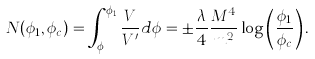<formula> <loc_0><loc_0><loc_500><loc_500>N ( \phi _ { 1 } , \phi _ { c } ) = \int _ { \phi _ { c } } ^ { \phi _ { 1 } } \frac { V } { V ^ { \prime } } d \phi = \pm \frac { \lambda } { 4 } \frac { M ^ { 4 } } { m ^ { 2 } } \log \left ( \frac { \phi _ { 1 } } { \phi _ { c } } \right ) .</formula> 